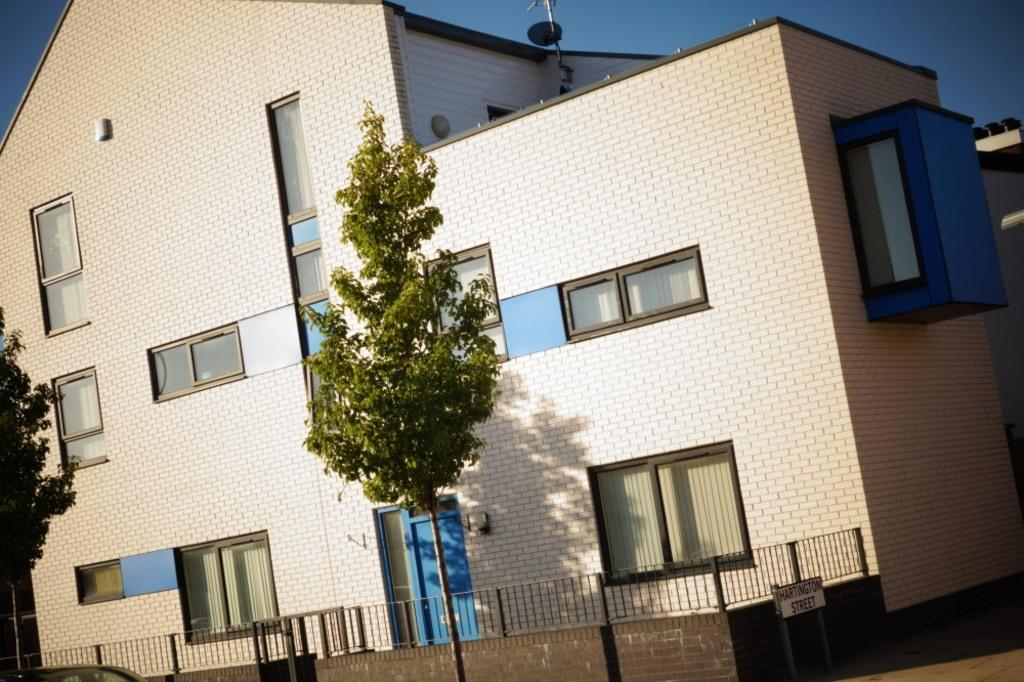What type of structure is present in the image? There is a house in the image. What type of natural element is present in the image? There is a tree in the image. What type of architectural feature is present in the image? There is a wall in the image. What type of barrier is present in the image? There is a fence in the image. What type of informational sign is present in the image? There is a sign board in the image. What type of openings are present in the house in the image? There are windows in the image. What type of entrance is present in the house in the image? There is a door in the image. What part of the natural environment is visible in the image? The sky is visible in the image. How much debt is the house in the image currently in? There is no information about the house's debt in the image. Where is the mailbox located in the image? There is no mailbox present in the image. What type of food is being served at the feast in the image? There is no feast present in the image. 